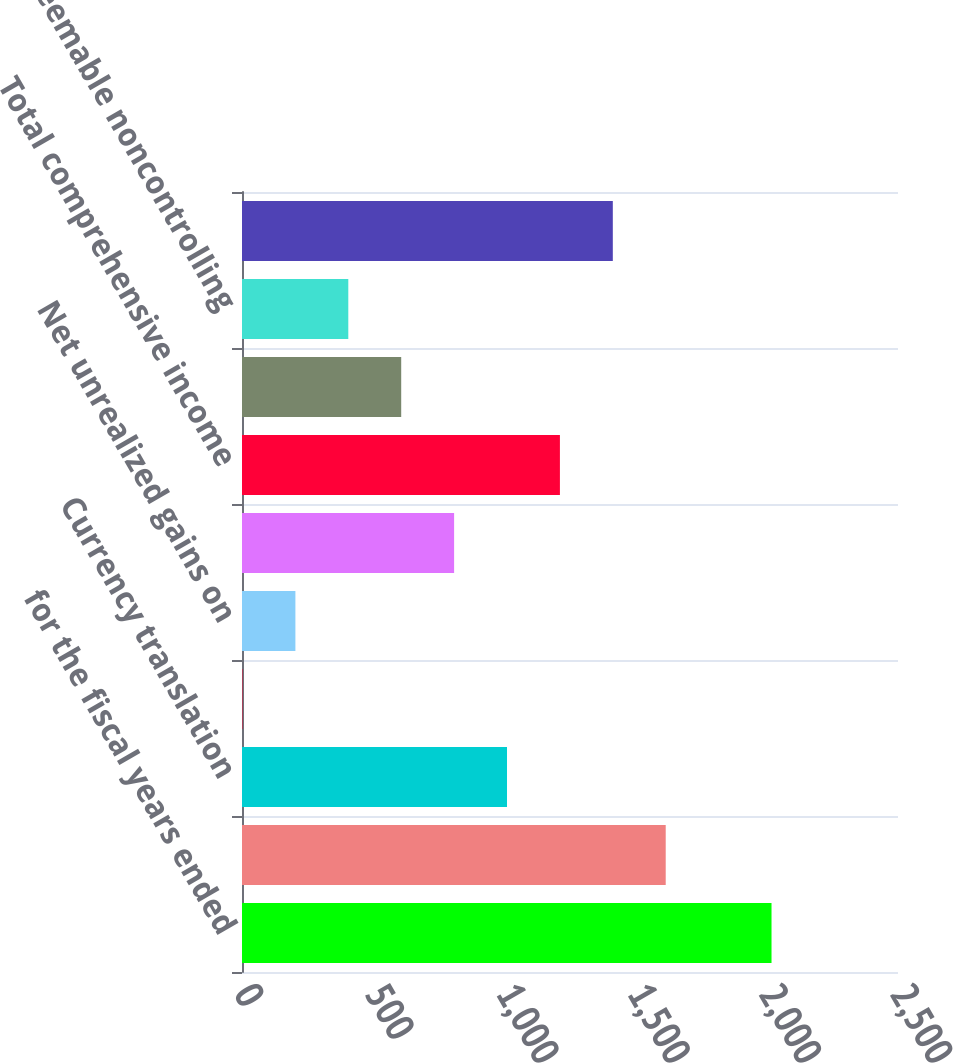Convert chart. <chart><loc_0><loc_0><loc_500><loc_500><bar_chart><fcel>for the fiscal years ended<fcel>Net Income<fcel>Currency translation<fcel>Net unrealized gains (losses)<fcel>Net unrealized gains on<fcel>Total other comprehensive<fcel>Total comprehensive income<fcel>Redeemable noncontrolling<fcel>Nonredeemable noncontrolling<fcel>Comprehensive Income<nl><fcel>2018<fcel>1614.78<fcel>1009.95<fcel>1.9<fcel>203.51<fcel>808.34<fcel>1211.56<fcel>606.73<fcel>405.12<fcel>1413.17<nl></chart> 